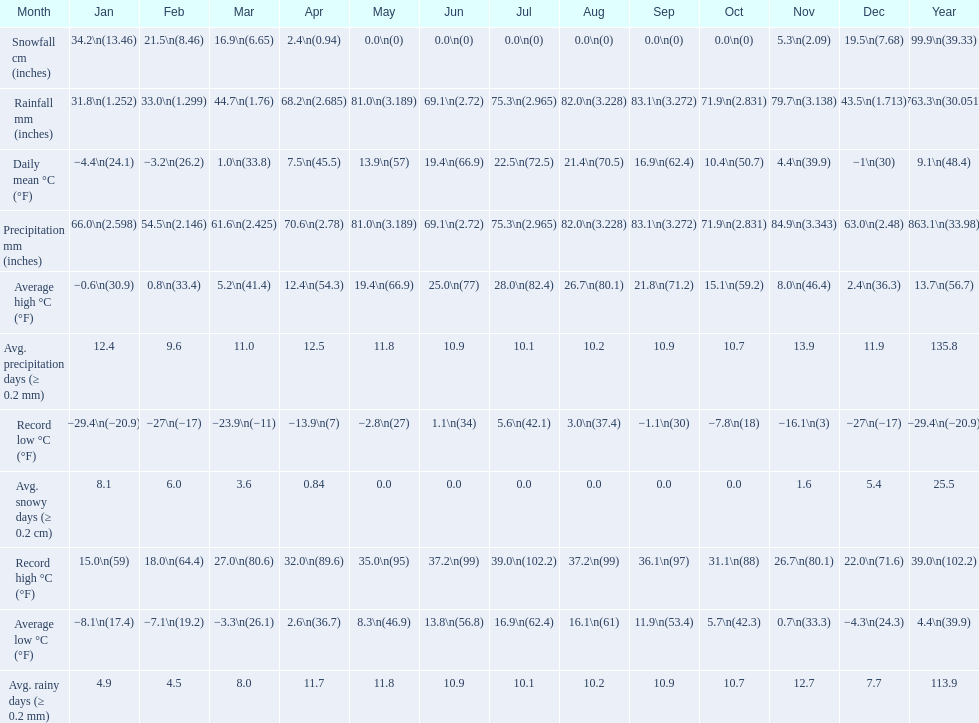Between january, october and december which month had the most rainfall? October. 